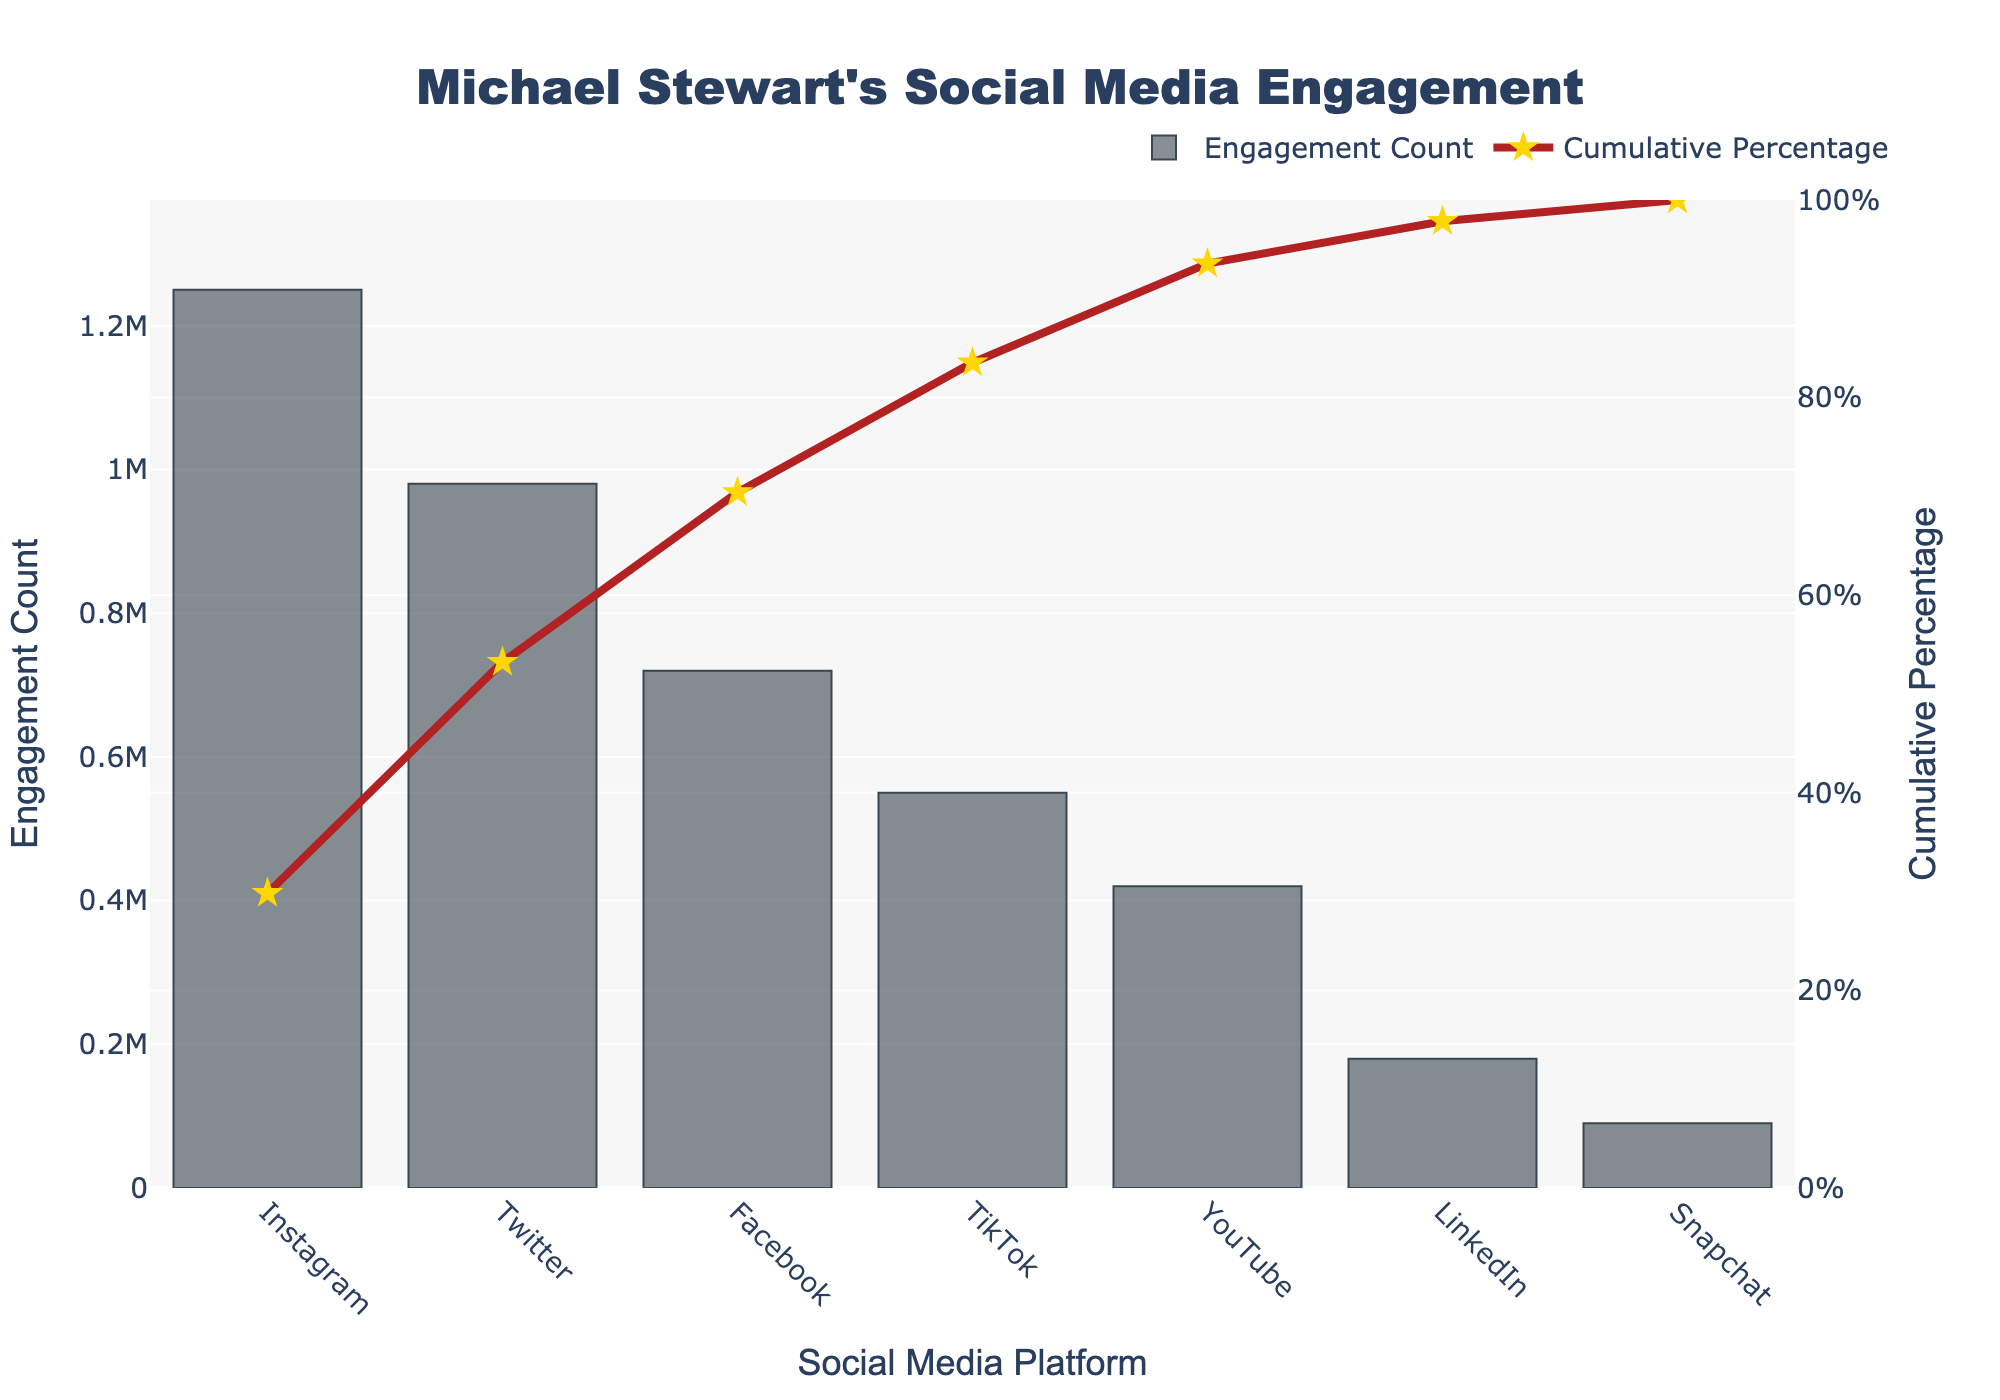How many platforms are shown in the chart? By counting the distinct bar segments in the chart, we can determine the number of platforms displayed. The x-axis labels indicate there are seven platforms.
Answer: Seven Which platform has the highest engagement count? The bar with the highest length on the chart represents the platform with the highest engagement count. This platform's label is Instagram.
Answer: Instagram What's the title of the figure? The figure's title is prominently displayed at the top of the chart. It reads: "Michael Stewart's Social Media Engagement".
Answer: Michael Stewart's Social Media Engagement What is the engagement count of TikTok? Locate the bar labelled TikTok on the x-axis and refer to its height along the y-axis labeled "Engagement Count". The count is 550,000.
Answer: 550,000 How much higher is Instagram's engagement compared to YouTube? Look at the heights of the bars for Instagram and YouTube. Instagram has an engagement count of 1,250,000, and YouTube has 420,000. Subtract the smaller number from the larger number: 1,250,000 - 420,000 = 830,000.
Answer: 830,000 What percentage of the total engagement is covered by the top two platforms, Instagram and Twitter? First, identify the engagement counts: Instagram has 1,250,000, and Twitter has 980,000. Sum these: 1,250,000 + 980,000 = 2,230,000. Then calculate the total engagement by summing all platform counts: 1,250,000 + 980,000 + 720,000 + 550,000 + 420,000 + 180,000 + 90,000 = 4,190,000. Finally, find the percentage: (2,230,000 / 4,190,000) * 100 ≈ 53.2%.
Answer: 53.2% Which platform marks the point where the cumulative percentage surpasses 50%? Examine the cumulative percentage line. The cumulative percentage exceeds 50% after TikTok, indicated by the y-axis value crossing the 50% mark after TikTok's plotted point.
Answer: TikTok What is the cumulative percentage reached by Facebook? Find the data point on the cumulative percentage line corresponding to Facebook. The cumulative percentage reaches around 68%.
Answer: 68% Which platform has a lower engagement count: LinkedIn or Snapchat? Compare the heights of the bars for LinkedIn and Snapchat. LinkedIn has 180,000, while Snapchat has 90,000. Thus, Snapchat has the lower count.
Answer: Snapchat How many platforms have an engagement count greater than 500,000? Identify the platforms whose bars extend above the 500,000 mark on the y-axis. These platforms are Instagram, Twitter, and Facebook.
Answer: Three 